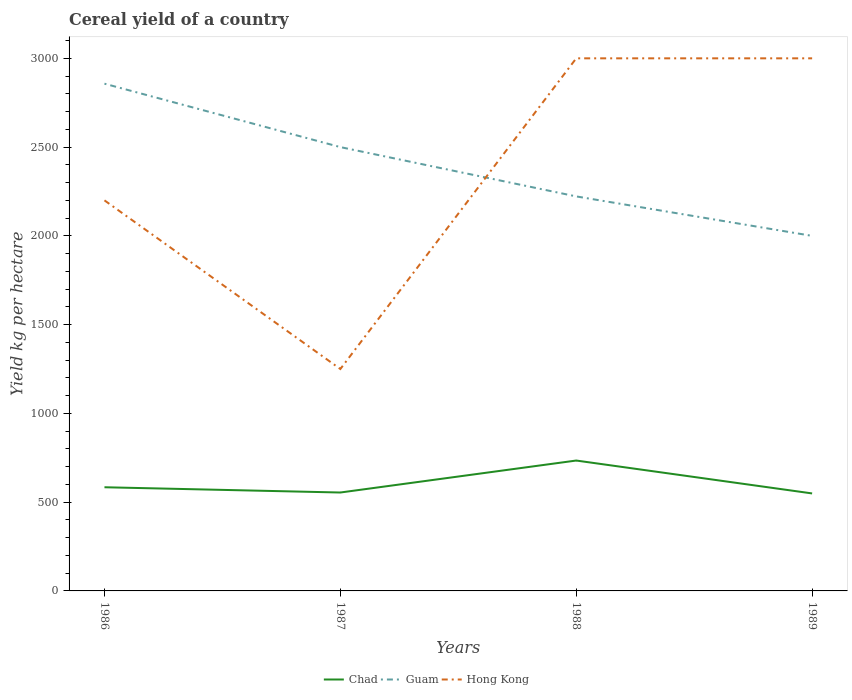Is the number of lines equal to the number of legend labels?
Your answer should be very brief. Yes. Across all years, what is the maximum total cereal yield in Chad?
Ensure brevity in your answer.  549.17. What is the total total cereal yield in Chad in the graph?
Give a very brief answer. 29.63. What is the difference between the highest and the second highest total cereal yield in Guam?
Ensure brevity in your answer.  857.14. What is the difference between two consecutive major ticks on the Y-axis?
Keep it short and to the point. 500. Does the graph contain any zero values?
Give a very brief answer. No. Does the graph contain grids?
Your response must be concise. No. Where does the legend appear in the graph?
Your response must be concise. Bottom center. How many legend labels are there?
Ensure brevity in your answer.  3. How are the legend labels stacked?
Ensure brevity in your answer.  Horizontal. What is the title of the graph?
Provide a short and direct response. Cereal yield of a country. Does "Seychelles" appear as one of the legend labels in the graph?
Offer a very short reply. No. What is the label or title of the X-axis?
Your answer should be very brief. Years. What is the label or title of the Y-axis?
Ensure brevity in your answer.  Yield kg per hectare. What is the Yield kg per hectare of Chad in 1986?
Give a very brief answer. 583.96. What is the Yield kg per hectare of Guam in 1986?
Your response must be concise. 2857.14. What is the Yield kg per hectare of Hong Kong in 1986?
Offer a very short reply. 2200. What is the Yield kg per hectare in Chad in 1987?
Offer a terse response. 554.32. What is the Yield kg per hectare of Guam in 1987?
Offer a very short reply. 2500. What is the Yield kg per hectare in Hong Kong in 1987?
Your answer should be compact. 1250. What is the Yield kg per hectare of Chad in 1988?
Keep it short and to the point. 734.41. What is the Yield kg per hectare of Guam in 1988?
Make the answer very short. 2222.22. What is the Yield kg per hectare in Hong Kong in 1988?
Provide a succinct answer. 3000. What is the Yield kg per hectare in Chad in 1989?
Offer a very short reply. 549.17. What is the Yield kg per hectare in Guam in 1989?
Your answer should be very brief. 2000. What is the Yield kg per hectare of Hong Kong in 1989?
Provide a short and direct response. 3000. Across all years, what is the maximum Yield kg per hectare of Chad?
Make the answer very short. 734.41. Across all years, what is the maximum Yield kg per hectare in Guam?
Keep it short and to the point. 2857.14. Across all years, what is the maximum Yield kg per hectare in Hong Kong?
Your answer should be compact. 3000. Across all years, what is the minimum Yield kg per hectare of Chad?
Give a very brief answer. 549.17. Across all years, what is the minimum Yield kg per hectare in Guam?
Offer a terse response. 2000. Across all years, what is the minimum Yield kg per hectare of Hong Kong?
Provide a succinct answer. 1250. What is the total Yield kg per hectare of Chad in the graph?
Give a very brief answer. 2421.86. What is the total Yield kg per hectare of Guam in the graph?
Offer a terse response. 9579.36. What is the total Yield kg per hectare in Hong Kong in the graph?
Offer a very short reply. 9450. What is the difference between the Yield kg per hectare in Chad in 1986 and that in 1987?
Ensure brevity in your answer.  29.64. What is the difference between the Yield kg per hectare in Guam in 1986 and that in 1987?
Provide a succinct answer. 357.14. What is the difference between the Yield kg per hectare of Hong Kong in 1986 and that in 1987?
Give a very brief answer. 950. What is the difference between the Yield kg per hectare of Chad in 1986 and that in 1988?
Your answer should be very brief. -150.46. What is the difference between the Yield kg per hectare in Guam in 1986 and that in 1988?
Give a very brief answer. 634.92. What is the difference between the Yield kg per hectare in Hong Kong in 1986 and that in 1988?
Keep it short and to the point. -800. What is the difference between the Yield kg per hectare in Chad in 1986 and that in 1989?
Offer a terse response. 34.79. What is the difference between the Yield kg per hectare in Guam in 1986 and that in 1989?
Provide a short and direct response. 857.14. What is the difference between the Yield kg per hectare of Hong Kong in 1986 and that in 1989?
Your answer should be very brief. -800. What is the difference between the Yield kg per hectare of Chad in 1987 and that in 1988?
Offer a terse response. -180.09. What is the difference between the Yield kg per hectare of Guam in 1987 and that in 1988?
Your response must be concise. 277.78. What is the difference between the Yield kg per hectare of Hong Kong in 1987 and that in 1988?
Your answer should be very brief. -1750. What is the difference between the Yield kg per hectare of Chad in 1987 and that in 1989?
Make the answer very short. 5.15. What is the difference between the Yield kg per hectare of Guam in 1987 and that in 1989?
Keep it short and to the point. 500. What is the difference between the Yield kg per hectare of Hong Kong in 1987 and that in 1989?
Your answer should be very brief. -1750. What is the difference between the Yield kg per hectare of Chad in 1988 and that in 1989?
Give a very brief answer. 185.24. What is the difference between the Yield kg per hectare in Guam in 1988 and that in 1989?
Give a very brief answer. 222.22. What is the difference between the Yield kg per hectare in Hong Kong in 1988 and that in 1989?
Ensure brevity in your answer.  0. What is the difference between the Yield kg per hectare in Chad in 1986 and the Yield kg per hectare in Guam in 1987?
Provide a short and direct response. -1916.04. What is the difference between the Yield kg per hectare in Chad in 1986 and the Yield kg per hectare in Hong Kong in 1987?
Keep it short and to the point. -666.04. What is the difference between the Yield kg per hectare of Guam in 1986 and the Yield kg per hectare of Hong Kong in 1987?
Offer a very short reply. 1607.14. What is the difference between the Yield kg per hectare of Chad in 1986 and the Yield kg per hectare of Guam in 1988?
Your answer should be very brief. -1638.27. What is the difference between the Yield kg per hectare in Chad in 1986 and the Yield kg per hectare in Hong Kong in 1988?
Provide a short and direct response. -2416.04. What is the difference between the Yield kg per hectare of Guam in 1986 and the Yield kg per hectare of Hong Kong in 1988?
Keep it short and to the point. -142.86. What is the difference between the Yield kg per hectare in Chad in 1986 and the Yield kg per hectare in Guam in 1989?
Give a very brief answer. -1416.04. What is the difference between the Yield kg per hectare in Chad in 1986 and the Yield kg per hectare in Hong Kong in 1989?
Your answer should be very brief. -2416.04. What is the difference between the Yield kg per hectare in Guam in 1986 and the Yield kg per hectare in Hong Kong in 1989?
Provide a succinct answer. -142.86. What is the difference between the Yield kg per hectare of Chad in 1987 and the Yield kg per hectare of Guam in 1988?
Give a very brief answer. -1667.9. What is the difference between the Yield kg per hectare in Chad in 1987 and the Yield kg per hectare in Hong Kong in 1988?
Keep it short and to the point. -2445.68. What is the difference between the Yield kg per hectare in Guam in 1987 and the Yield kg per hectare in Hong Kong in 1988?
Provide a succinct answer. -500. What is the difference between the Yield kg per hectare in Chad in 1987 and the Yield kg per hectare in Guam in 1989?
Provide a short and direct response. -1445.68. What is the difference between the Yield kg per hectare of Chad in 1987 and the Yield kg per hectare of Hong Kong in 1989?
Ensure brevity in your answer.  -2445.68. What is the difference between the Yield kg per hectare in Guam in 1987 and the Yield kg per hectare in Hong Kong in 1989?
Provide a succinct answer. -500. What is the difference between the Yield kg per hectare of Chad in 1988 and the Yield kg per hectare of Guam in 1989?
Your answer should be compact. -1265.59. What is the difference between the Yield kg per hectare of Chad in 1988 and the Yield kg per hectare of Hong Kong in 1989?
Offer a very short reply. -2265.59. What is the difference between the Yield kg per hectare in Guam in 1988 and the Yield kg per hectare in Hong Kong in 1989?
Your answer should be compact. -777.78. What is the average Yield kg per hectare in Chad per year?
Provide a short and direct response. 605.46. What is the average Yield kg per hectare of Guam per year?
Offer a terse response. 2394.84. What is the average Yield kg per hectare of Hong Kong per year?
Provide a succinct answer. 2362.5. In the year 1986, what is the difference between the Yield kg per hectare of Chad and Yield kg per hectare of Guam?
Your response must be concise. -2273.19. In the year 1986, what is the difference between the Yield kg per hectare of Chad and Yield kg per hectare of Hong Kong?
Provide a succinct answer. -1616.04. In the year 1986, what is the difference between the Yield kg per hectare of Guam and Yield kg per hectare of Hong Kong?
Ensure brevity in your answer.  657.14. In the year 1987, what is the difference between the Yield kg per hectare of Chad and Yield kg per hectare of Guam?
Ensure brevity in your answer.  -1945.68. In the year 1987, what is the difference between the Yield kg per hectare of Chad and Yield kg per hectare of Hong Kong?
Offer a terse response. -695.68. In the year 1987, what is the difference between the Yield kg per hectare of Guam and Yield kg per hectare of Hong Kong?
Your answer should be compact. 1250. In the year 1988, what is the difference between the Yield kg per hectare of Chad and Yield kg per hectare of Guam?
Ensure brevity in your answer.  -1487.81. In the year 1988, what is the difference between the Yield kg per hectare in Chad and Yield kg per hectare in Hong Kong?
Ensure brevity in your answer.  -2265.59. In the year 1988, what is the difference between the Yield kg per hectare in Guam and Yield kg per hectare in Hong Kong?
Your response must be concise. -777.78. In the year 1989, what is the difference between the Yield kg per hectare of Chad and Yield kg per hectare of Guam?
Your answer should be very brief. -1450.83. In the year 1989, what is the difference between the Yield kg per hectare in Chad and Yield kg per hectare in Hong Kong?
Your answer should be very brief. -2450.83. In the year 1989, what is the difference between the Yield kg per hectare in Guam and Yield kg per hectare in Hong Kong?
Your answer should be very brief. -1000. What is the ratio of the Yield kg per hectare in Chad in 1986 to that in 1987?
Your response must be concise. 1.05. What is the ratio of the Yield kg per hectare of Hong Kong in 1986 to that in 1987?
Offer a terse response. 1.76. What is the ratio of the Yield kg per hectare in Chad in 1986 to that in 1988?
Your answer should be compact. 0.8. What is the ratio of the Yield kg per hectare in Hong Kong in 1986 to that in 1988?
Your answer should be very brief. 0.73. What is the ratio of the Yield kg per hectare in Chad in 1986 to that in 1989?
Provide a succinct answer. 1.06. What is the ratio of the Yield kg per hectare of Guam in 1986 to that in 1989?
Offer a terse response. 1.43. What is the ratio of the Yield kg per hectare in Hong Kong in 1986 to that in 1989?
Ensure brevity in your answer.  0.73. What is the ratio of the Yield kg per hectare in Chad in 1987 to that in 1988?
Provide a short and direct response. 0.75. What is the ratio of the Yield kg per hectare in Guam in 1987 to that in 1988?
Your response must be concise. 1.12. What is the ratio of the Yield kg per hectare of Hong Kong in 1987 to that in 1988?
Offer a terse response. 0.42. What is the ratio of the Yield kg per hectare of Chad in 1987 to that in 1989?
Keep it short and to the point. 1.01. What is the ratio of the Yield kg per hectare of Hong Kong in 1987 to that in 1989?
Your answer should be compact. 0.42. What is the ratio of the Yield kg per hectare in Chad in 1988 to that in 1989?
Offer a very short reply. 1.34. What is the ratio of the Yield kg per hectare of Hong Kong in 1988 to that in 1989?
Make the answer very short. 1. What is the difference between the highest and the second highest Yield kg per hectare in Chad?
Ensure brevity in your answer.  150.46. What is the difference between the highest and the second highest Yield kg per hectare in Guam?
Offer a very short reply. 357.14. What is the difference between the highest and the second highest Yield kg per hectare of Hong Kong?
Keep it short and to the point. 0. What is the difference between the highest and the lowest Yield kg per hectare in Chad?
Provide a short and direct response. 185.24. What is the difference between the highest and the lowest Yield kg per hectare of Guam?
Ensure brevity in your answer.  857.14. What is the difference between the highest and the lowest Yield kg per hectare in Hong Kong?
Your answer should be compact. 1750. 